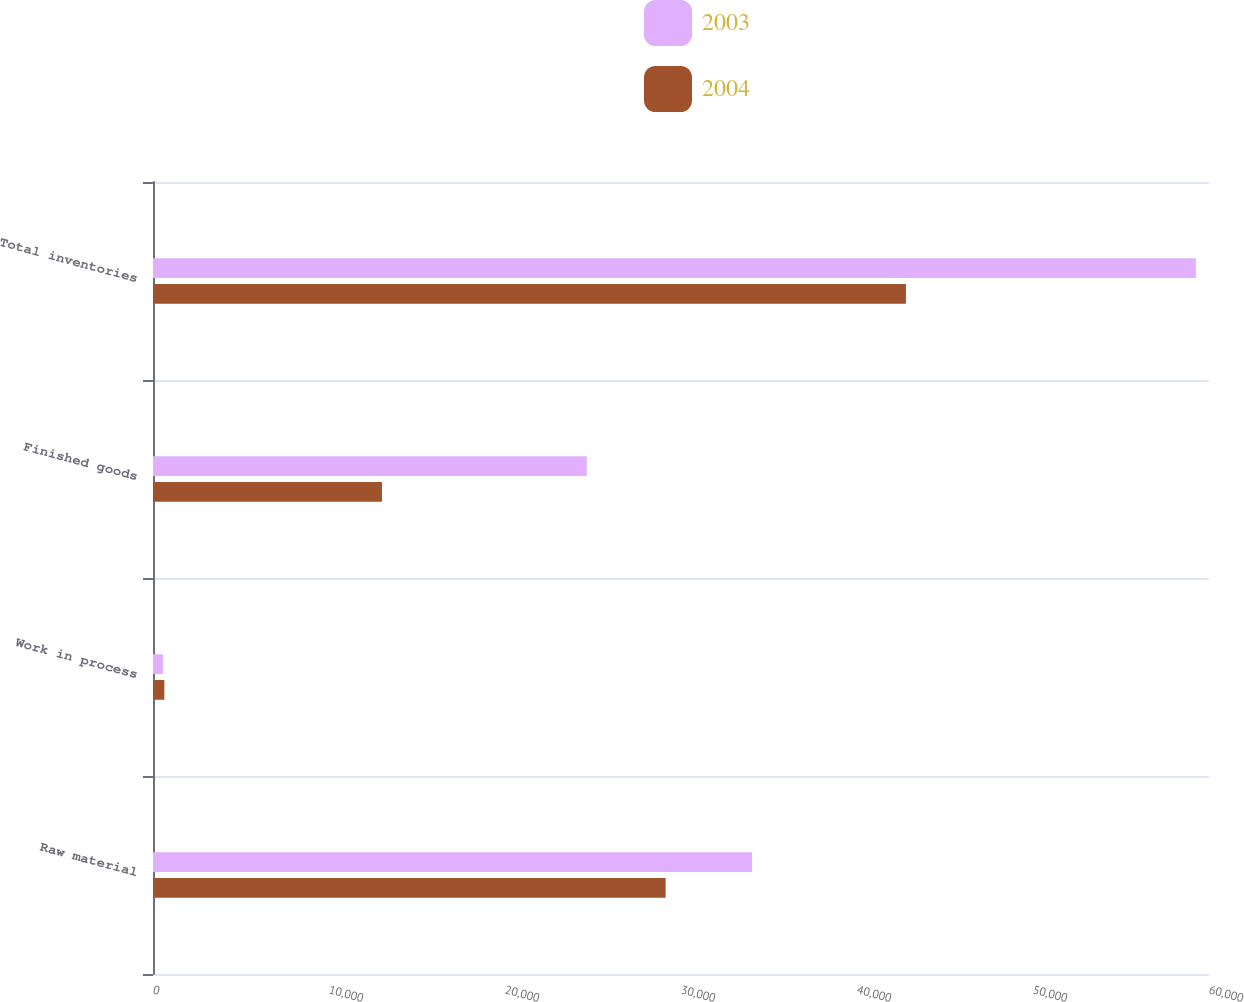Convert chart. <chart><loc_0><loc_0><loc_500><loc_500><stacked_bar_chart><ecel><fcel>Raw material<fcel>Work in process<fcel>Finished goods<fcel>Total inventories<nl><fcel>2003<fcel>34041<fcel>569<fcel>24645<fcel>59255<nl><fcel>2004<fcel>29127<fcel>645<fcel>13009<fcel>42781<nl></chart> 